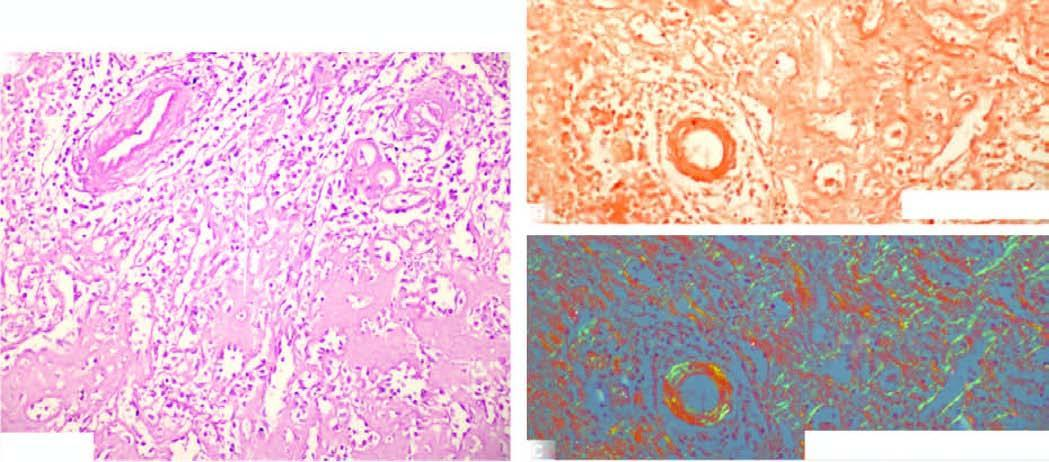does congo red staining show congophilia as seen by red-pink colour?
Answer the question using a single word or phrase. Yes 